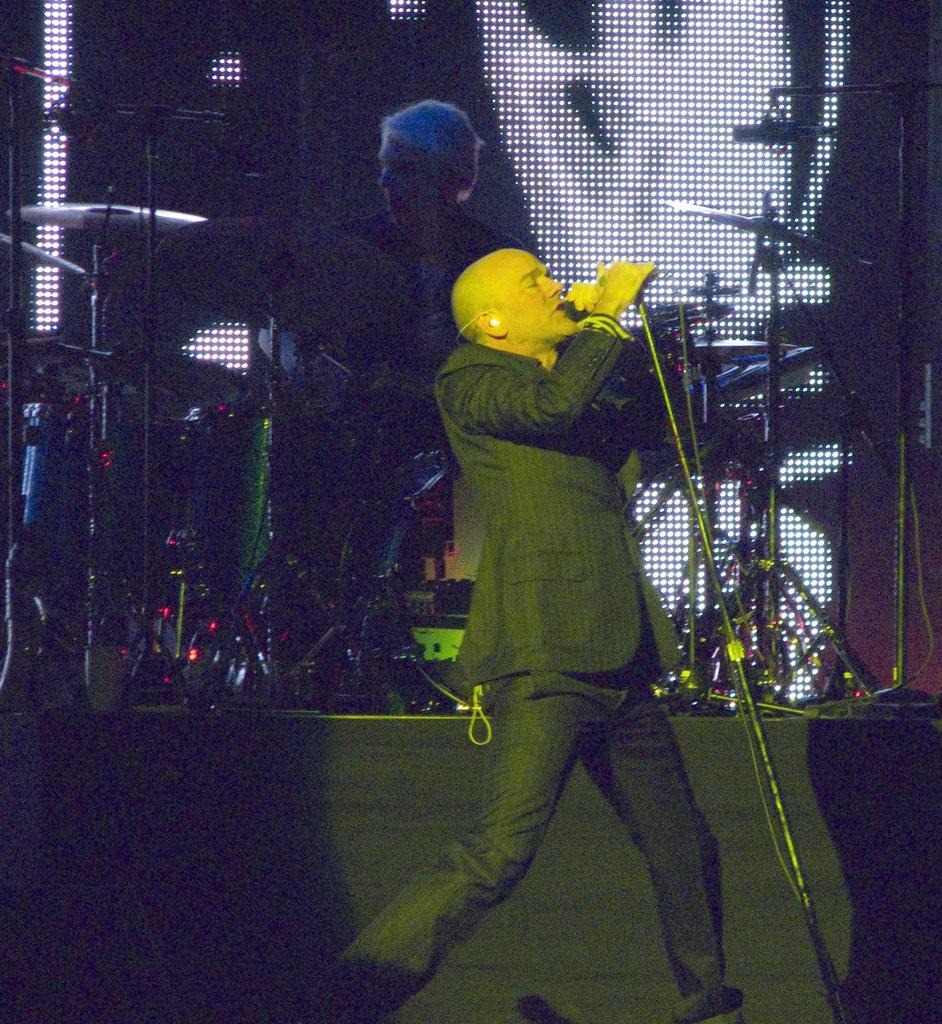What is the main activity taking place in the image? There is a person performing on the stage. What is the person holding in his hand? The person is holding a mic in his hand. What can be seen in the background of the image? There are musical instruments and a display screen in the background. What type of pancake is being served on the display screen in the image? There is no pancake present in the image, and the display screen does not show any food items. 